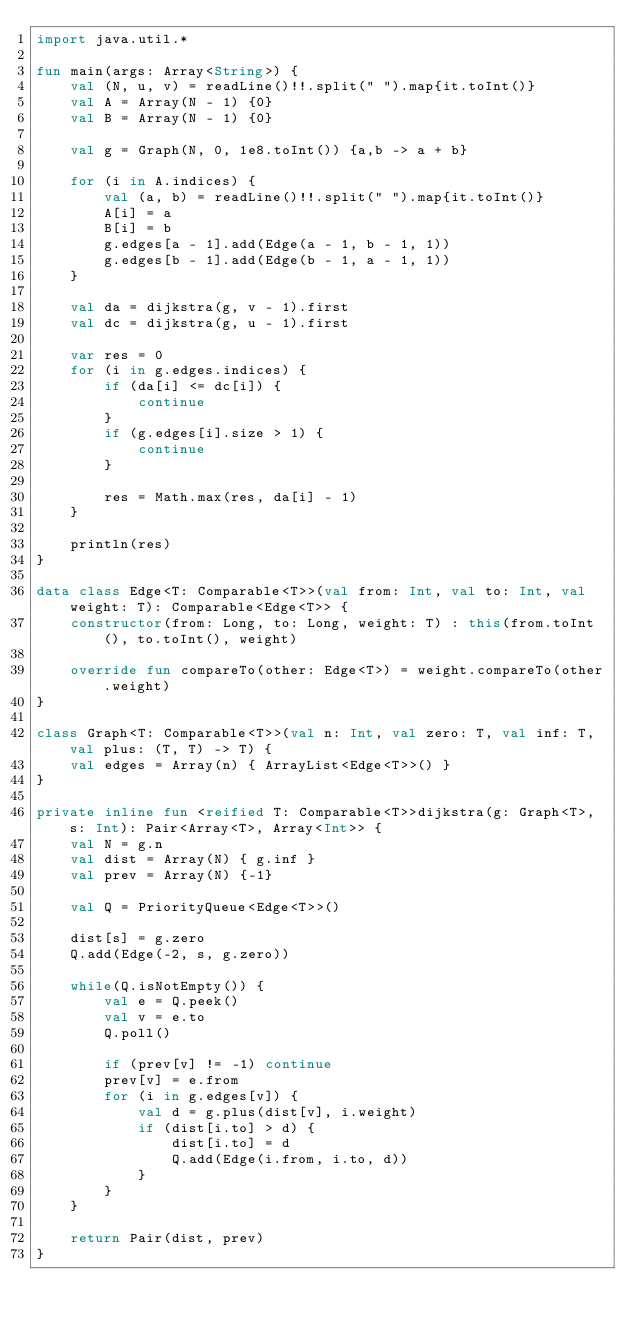Convert code to text. <code><loc_0><loc_0><loc_500><loc_500><_Kotlin_>import java.util.*

fun main(args: Array<String>) {
    val (N, u, v) = readLine()!!.split(" ").map{it.toInt()}
    val A = Array(N - 1) {0}
    val B = Array(N - 1) {0}

    val g = Graph(N, 0, 1e8.toInt()) {a,b -> a + b}

    for (i in A.indices) {
        val (a, b) = readLine()!!.split(" ").map{it.toInt()}
        A[i] = a
        B[i] = b
        g.edges[a - 1].add(Edge(a - 1, b - 1, 1))
        g.edges[b - 1].add(Edge(b - 1, a - 1, 1))
    }

    val da = dijkstra(g, v - 1).first
    val dc = dijkstra(g, u - 1).first

    var res = 0
    for (i in g.edges.indices) {
        if (da[i] <= dc[i]) {
            continue
        }
        if (g.edges[i].size > 1) {
            continue
        }

        res = Math.max(res, da[i] - 1)
    }

    println(res)
}

data class Edge<T: Comparable<T>>(val from: Int, val to: Int, val weight: T): Comparable<Edge<T>> {
    constructor(from: Long, to: Long, weight: T) : this(from.toInt(), to.toInt(), weight)

    override fun compareTo(other: Edge<T>) = weight.compareTo(other.weight)
}

class Graph<T: Comparable<T>>(val n: Int, val zero: T, val inf: T, val plus: (T, T) -> T) {
    val edges = Array(n) { ArrayList<Edge<T>>() }
}

private inline fun <reified T: Comparable<T>>dijkstra(g: Graph<T>, s: Int): Pair<Array<T>, Array<Int>> {
    val N = g.n
    val dist = Array(N) { g.inf }
    val prev = Array(N) {-1}

    val Q = PriorityQueue<Edge<T>>()

    dist[s] = g.zero
    Q.add(Edge(-2, s, g.zero))

    while(Q.isNotEmpty()) {
        val e = Q.peek()
        val v = e.to
        Q.poll()

        if (prev[v] != -1) continue
        prev[v] = e.from
        for (i in g.edges[v]) {
            val d = g.plus(dist[v], i.weight)
            if (dist[i.to] > d) {
                dist[i.to] = d
                Q.add(Edge(i.from, i.to, d))
            }
        }
    }

    return Pair(dist, prev)
}
</code> 